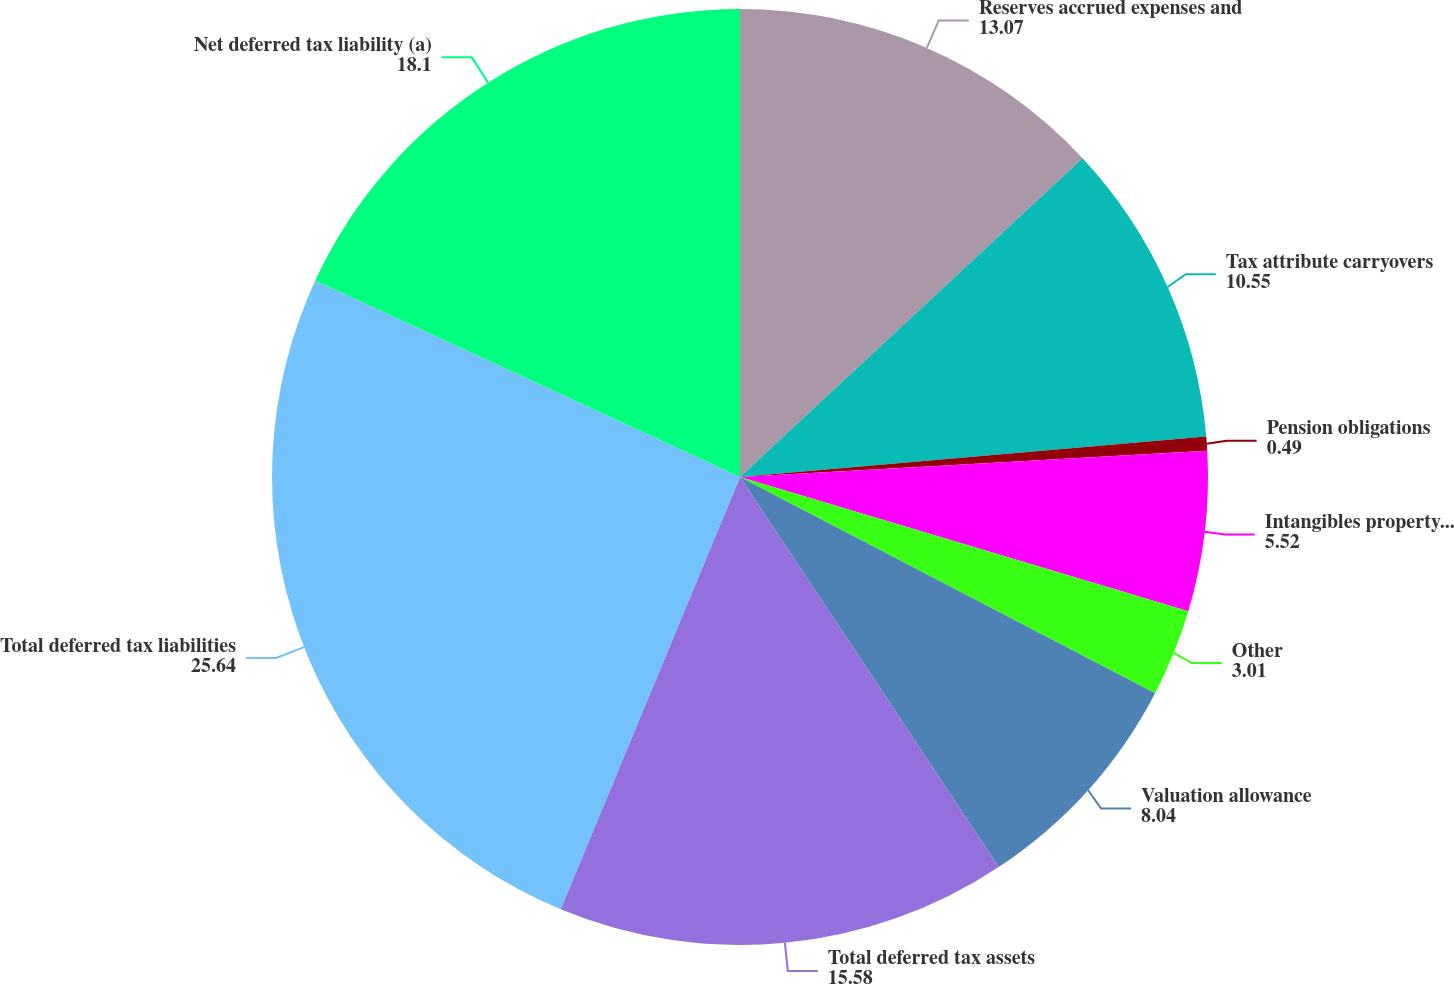Convert chart. <chart><loc_0><loc_0><loc_500><loc_500><pie_chart><fcel>Reserves accrued expenses and<fcel>Tax attribute carryovers<fcel>Pension obligations<fcel>Intangibles property and<fcel>Other<fcel>Valuation allowance<fcel>Total deferred tax assets<fcel>Total deferred tax liabilities<fcel>Net deferred tax liability (a)<nl><fcel>13.07%<fcel>10.55%<fcel>0.49%<fcel>5.52%<fcel>3.01%<fcel>8.04%<fcel>15.58%<fcel>25.64%<fcel>18.1%<nl></chart> 